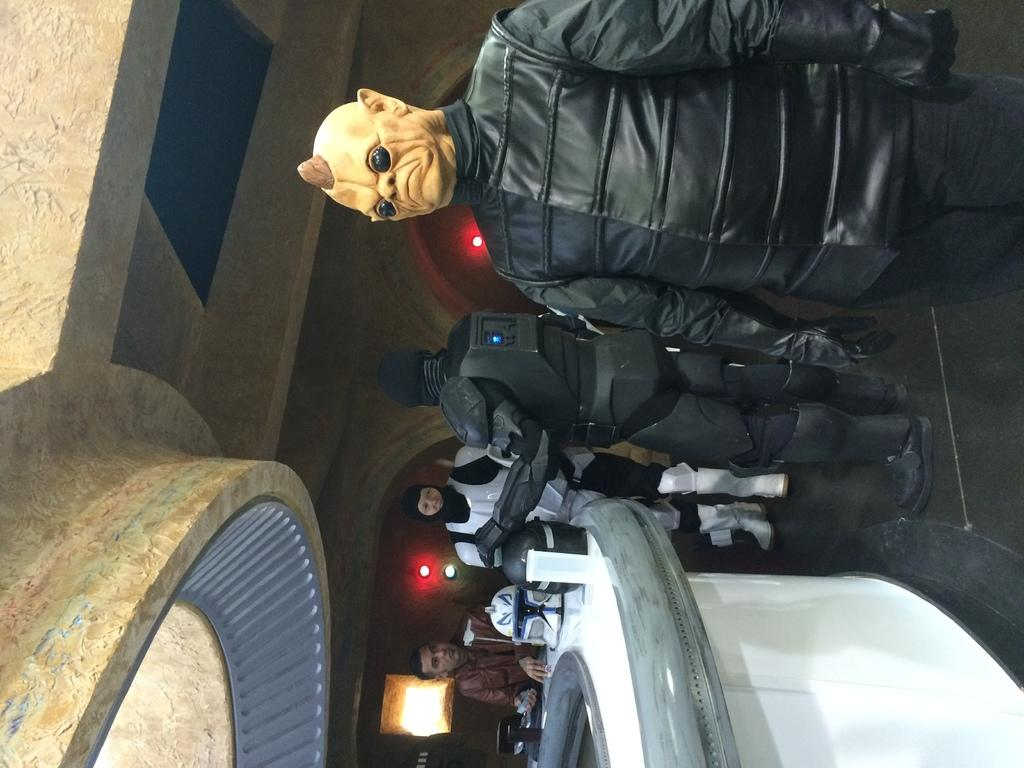What can be seen in the image? There are people standing in the image. What is present in the image besides the people? There is a table in the image. What is hanging from the ceiling in the image? Lights are attached to the ceiling. What is visible in the background of the image? There is a wall in the background of the image. What type of furniture is being taxed in the image? There is no furniture or tax-related information present in the image. 